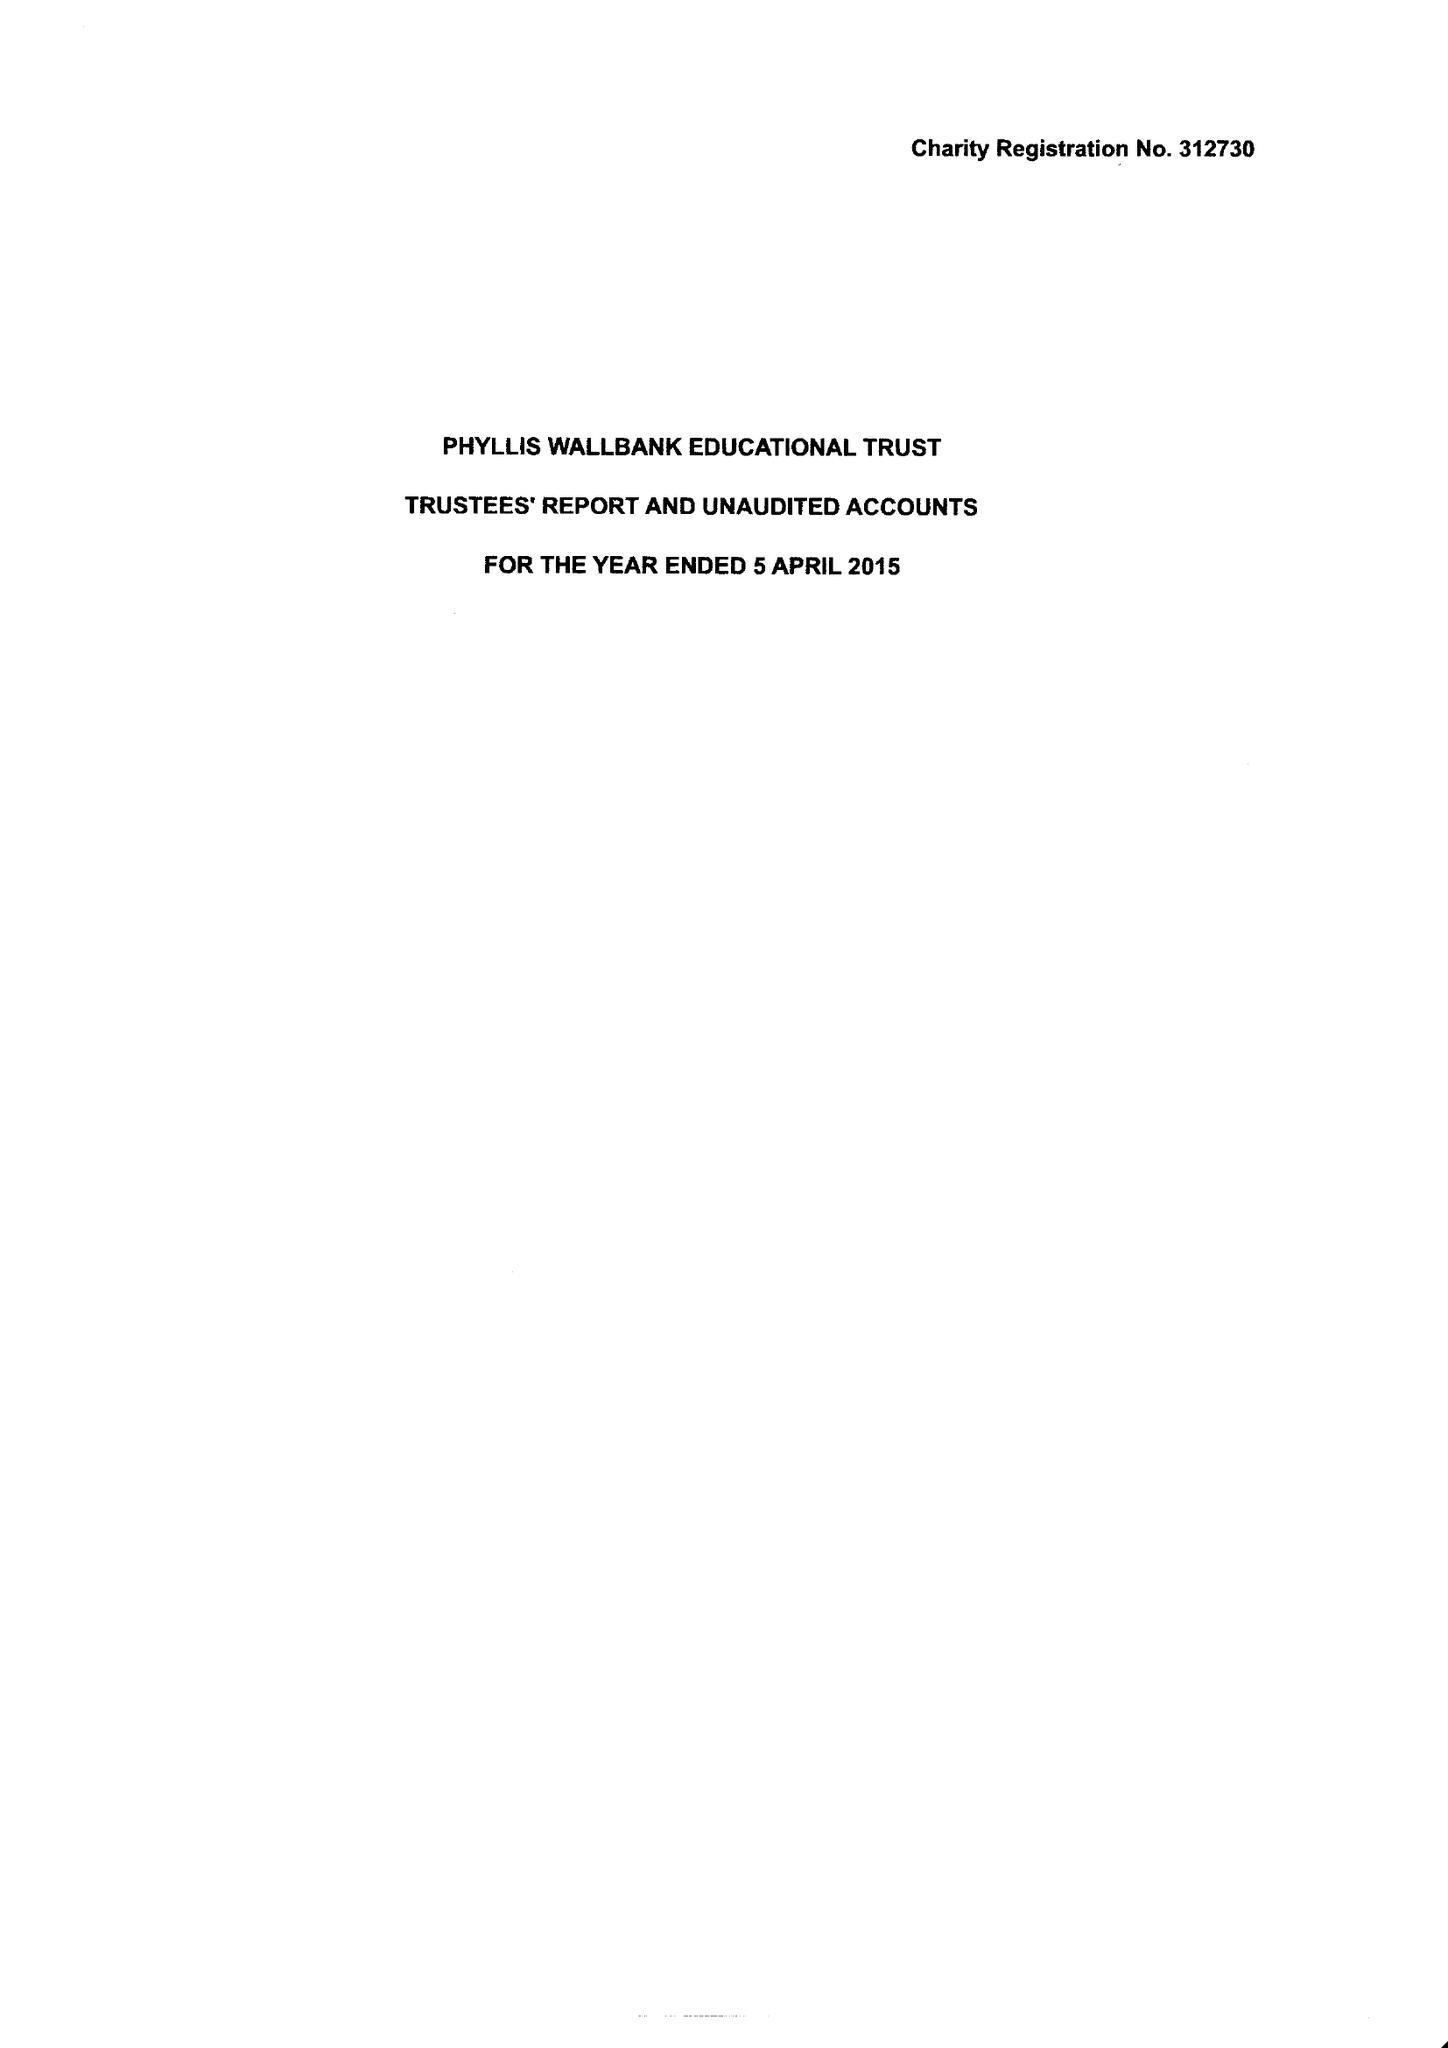What is the value for the income_annually_in_british_pounds?
Answer the question using a single word or phrase. 93860.00 